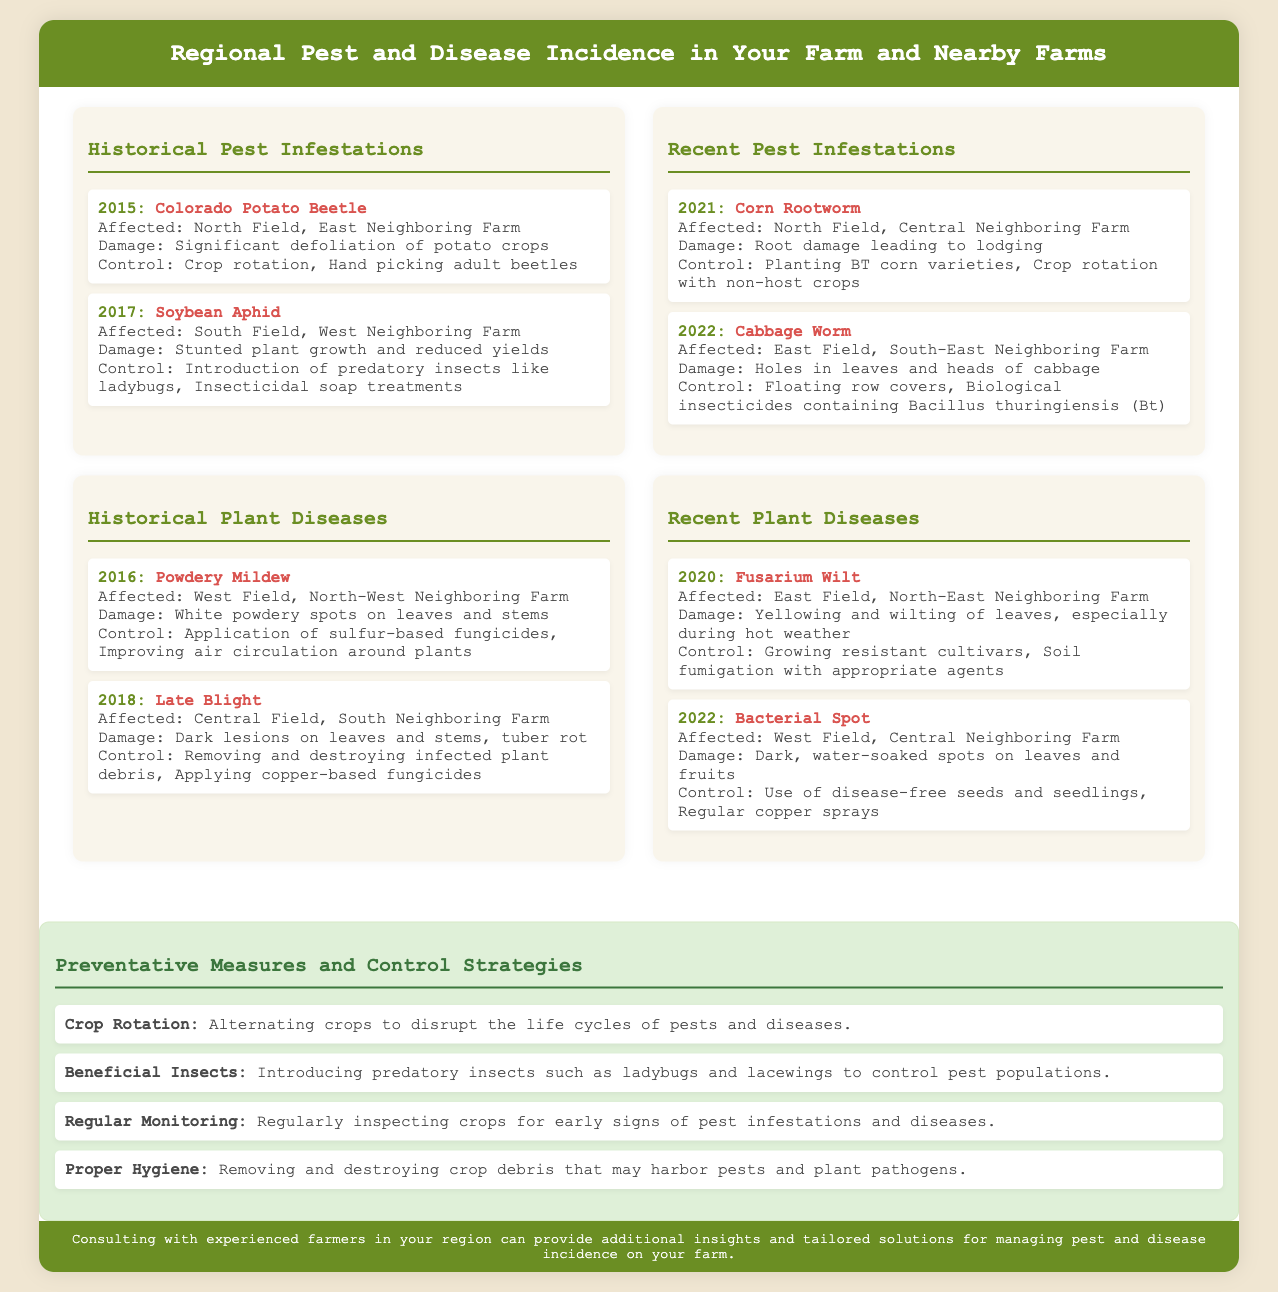What was the pest affecting the North Field in 2015? The document states that the Colorado Potato Beetle affected the North Field in 2015.
Answer: Colorado Potato Beetle What was the control method for the Corn Rootworm in 2021? The document mentions that planting BT corn varieties was a control method for the Corn Rootworm in 2021.
Answer: Planting BT corn varieties In what year did Powdery Mildew affect the West Field? According to the document, Powdery Mildew affected the West Field in 2016.
Answer: 2016 What is one preventative measure listed in the document? The document outlines several preventative measures, one of which is Crop Rotation.
Answer: Crop Rotation What type of damage did Cabbage Worm cause in 2022? The document indicates that the Cabbage Worm caused holes in leaves and heads of cabbage in 2022.
Answer: Holes in leaves and heads of cabbage Which field was affected by Fusarium Wilt in 2020? The document states that the East Field was affected by Fusarium Wilt in 2020.
Answer: East Field What was the primary control method for Late Blight in 2018? The document highlights that removing and destroying infected plant debris was a control method for Late Blight in 2018.
Answer: Removing and destroying infected plant debris What significant pest was introduced in 2017 at the South Field? According to the document, the Soybean Aphid was a significant pest introduced in 2017 at the South Field.
Answer: Soybean Aphid What was the main cause of damage from Bacterial Spot in 2022? The document states that Bacterial Spot caused dark, water-soaked spots on leaves and fruits in 2022.
Answer: Dark, water-soaked spots on leaves and fruits 